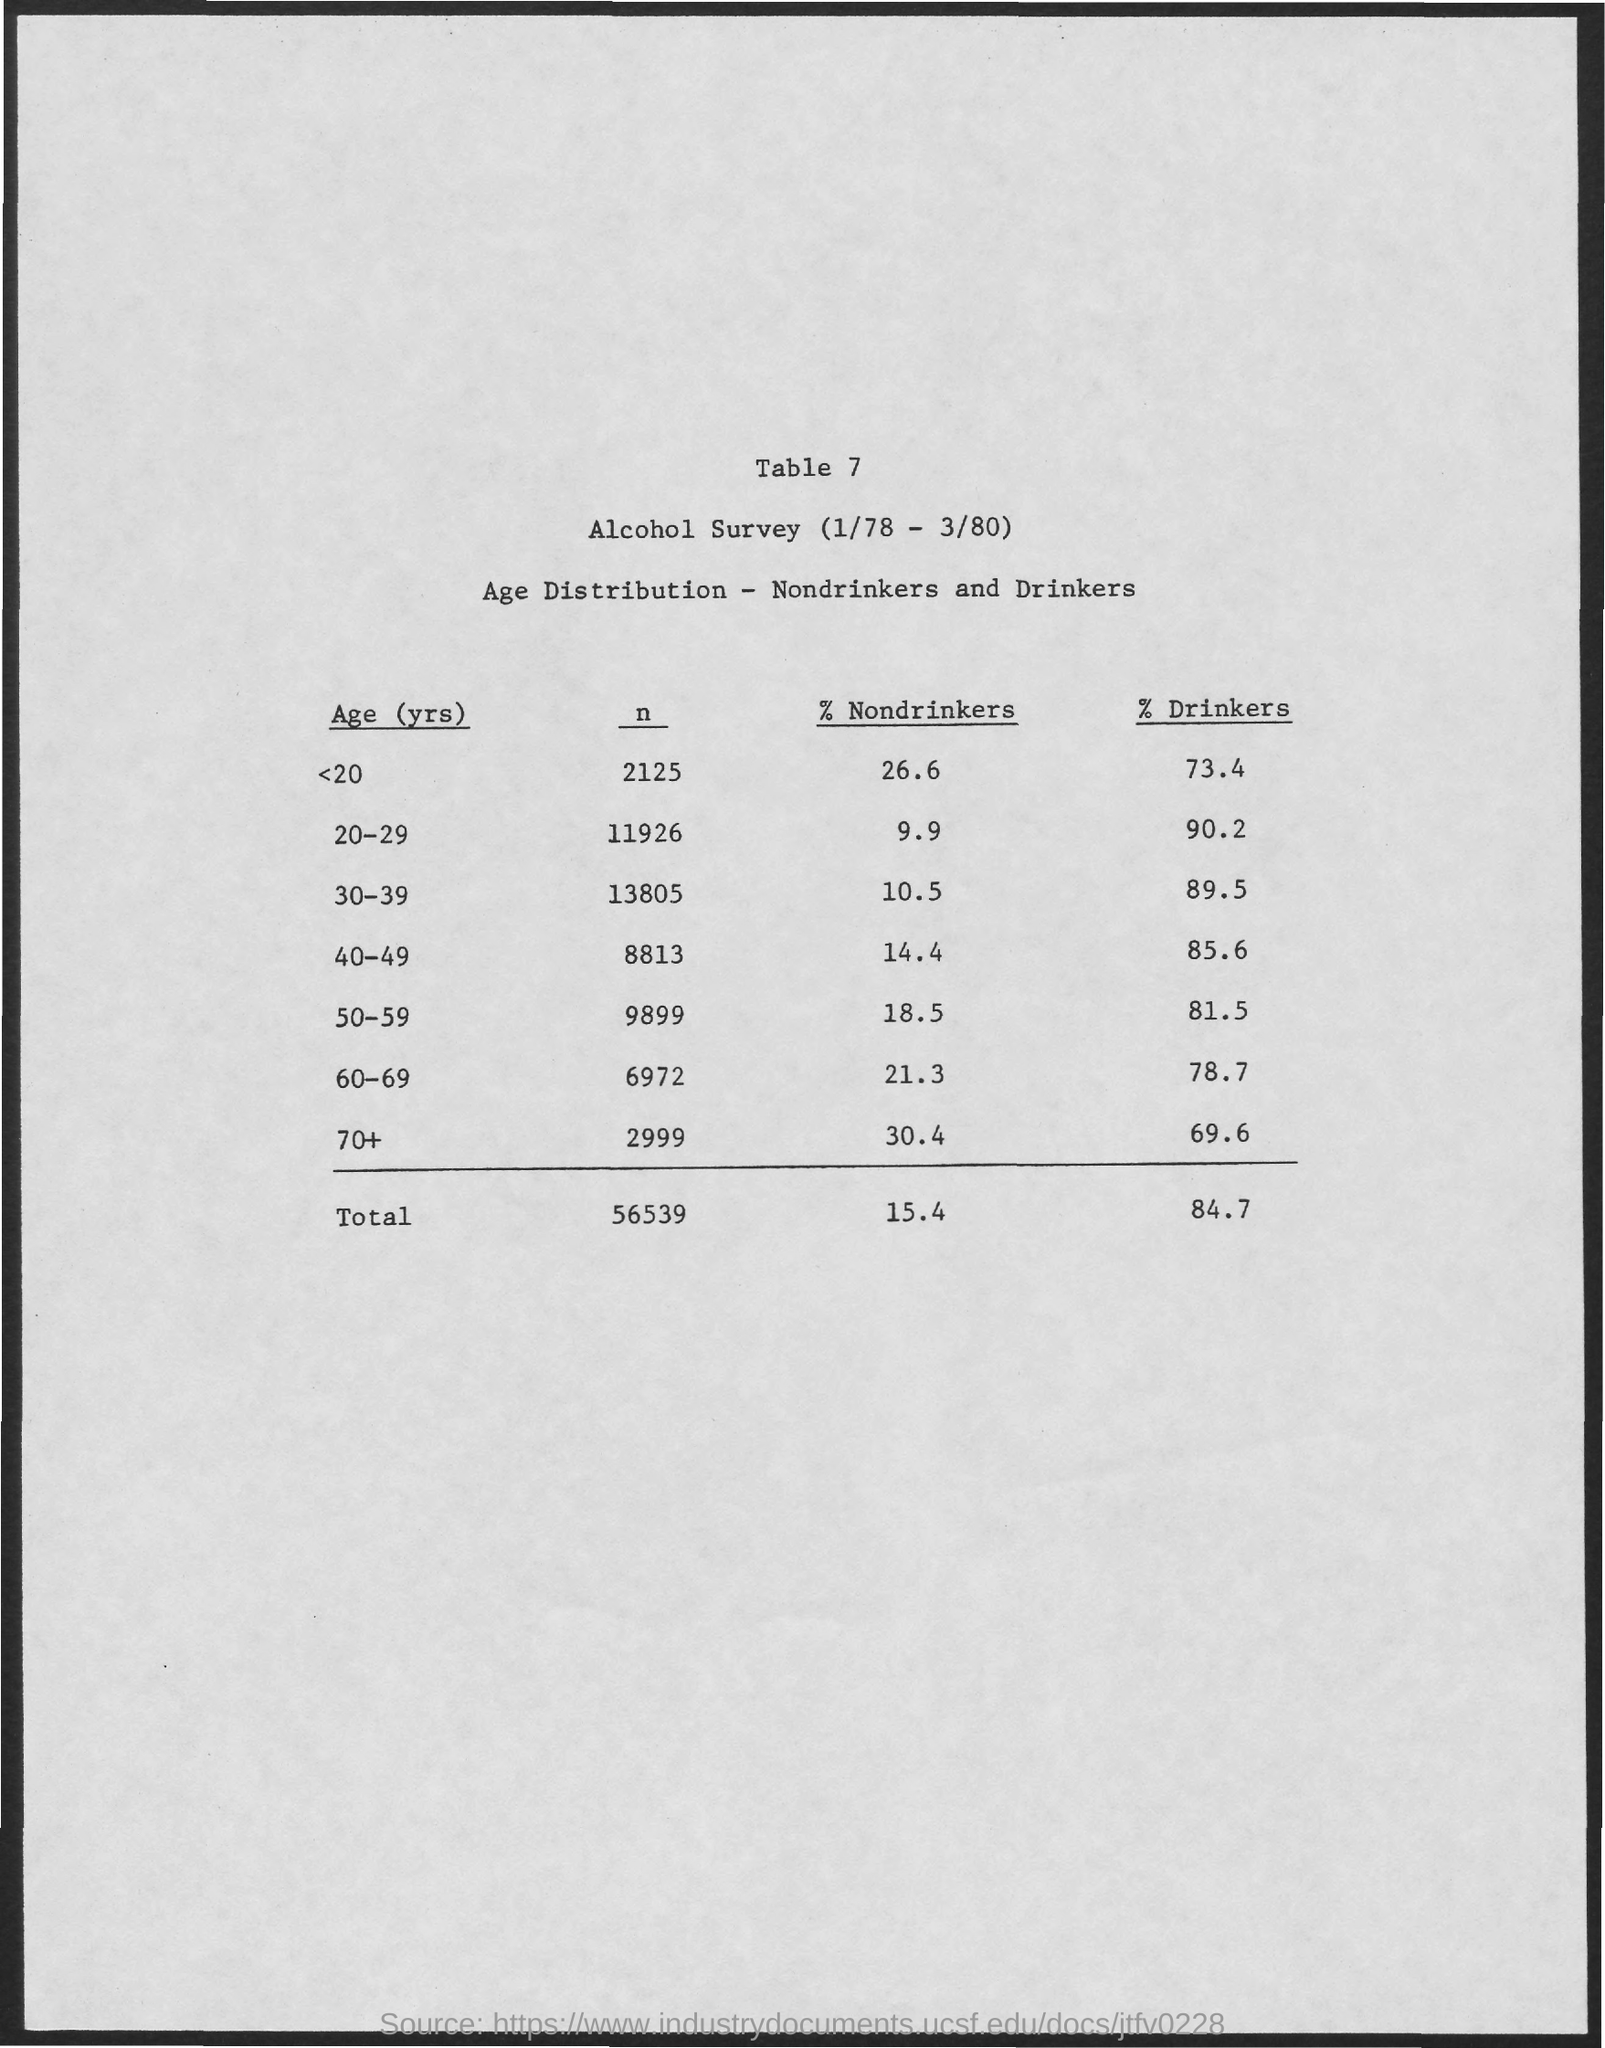What is the table number?
Offer a terse response. Table 7. What is the percentage of drinkers below the age of 20?
Provide a succinct answer. 73.4. What is the percentage of nondrinkers below the age of 20?
Ensure brevity in your answer.  26.6. The percentage of nondrinkers is high in which age group?
Give a very brief answer. 70+. The percentage of nondrinkers is low in which age group?
Your response must be concise. 20-29. The percentage of drinkers is high in which age group?
Provide a short and direct response. 20-29. 